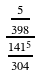Convert formula to latex. <formula><loc_0><loc_0><loc_500><loc_500>\frac { \frac { 5 } { 3 9 8 } } { \frac { 1 4 1 ^ { 5 } } { 3 0 4 } }</formula> 